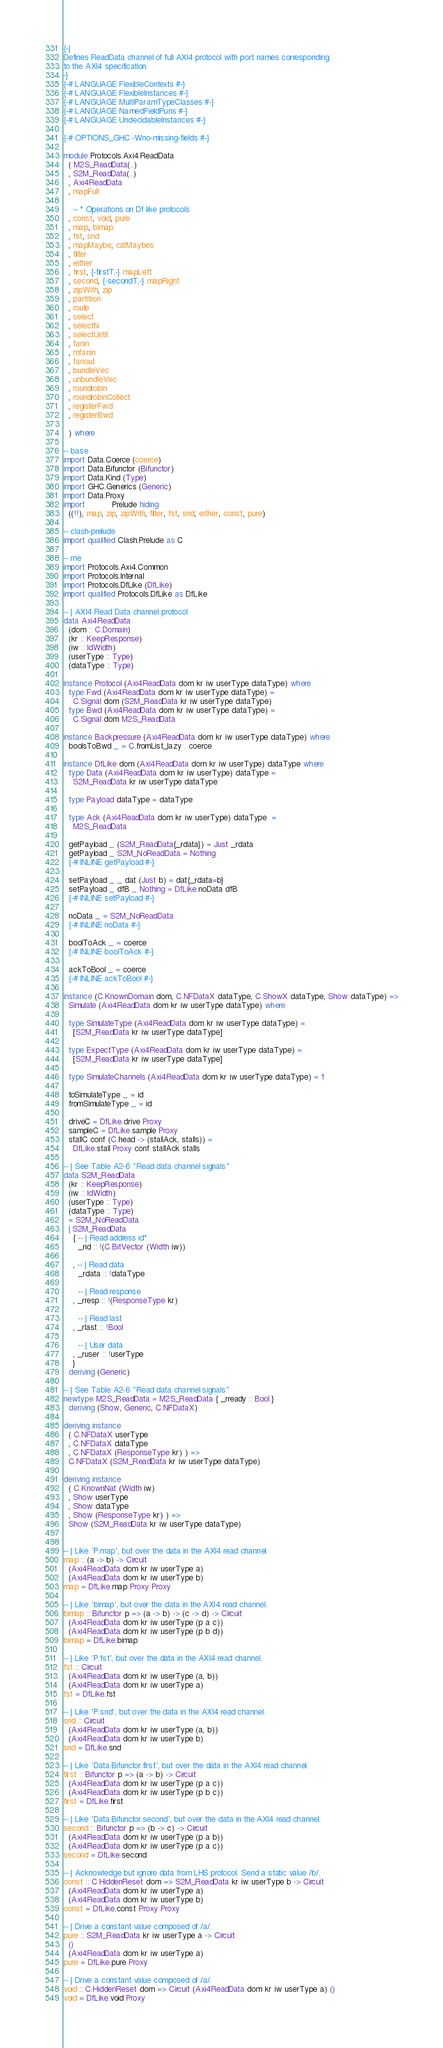<code> <loc_0><loc_0><loc_500><loc_500><_Haskell_>{-|
Defines ReadData channel of full AXI4 protocol with port names corresponding
to the AXI4 specification.
-}
{-# LANGUAGE FlexibleContexts #-}
{-# LANGUAGE FlexibleInstances #-}
{-# LANGUAGE MultiParamTypeClasses #-}
{-# LANGUAGE NamedFieldPuns #-}
{-# LANGUAGE UndecidableInstances #-}

{-# OPTIONS_GHC -Wno-missing-fields #-}

module Protocols.Axi4.ReadData
  ( M2S_ReadData(..)
  , S2M_ReadData(..)
  , Axi4ReadData
  , mapFull

    -- * Operations on Df like protocols
  , const, void, pure
  , map, bimap
  , fst, snd
  , mapMaybe, catMaybes
  , filter
  , either
  , first, {-firstT,-} mapLeft
  , second, {-secondT,-} mapRight
  , zipWith, zip
  , partition
  , route
  , select
  , selectN
  , selectUntil
  , fanin
  , mfanin
  , fanout
  , bundleVec
  , unbundleVec
  , roundrobin
  , roundrobinCollect
  , registerFwd
  , registerBwd

  ) where

-- base
import Data.Coerce (coerce)
import Data.Bifunctor (Bifunctor)
import Data.Kind (Type)
import GHC.Generics (Generic)
import Data.Proxy
import           Prelude hiding
  ((!!), map, zip, zipWith, filter, fst, snd, either, const, pure)

-- clash-prelude
import qualified Clash.Prelude as C

-- me
import Protocols.Axi4.Common
import Protocols.Internal
import Protocols.DfLike (DfLike)
import qualified Protocols.DfLike as DfLike

-- | AXI4 Read Data channel protocol
data Axi4ReadData
  (dom :: C.Domain)
  (kr :: KeepResponse)
  (iw :: IdWidth)
  (userType :: Type)
  (dataType :: Type)

instance Protocol (Axi4ReadData dom kr iw userType dataType) where
  type Fwd (Axi4ReadData dom kr iw userType dataType) =
    C.Signal dom (S2M_ReadData kr iw userType dataType)
  type Bwd (Axi4ReadData dom kr iw userType dataType) =
    C.Signal dom M2S_ReadData

instance Backpressure (Axi4ReadData dom kr iw userType dataType) where
  boolsToBwd _ = C.fromList_lazy . coerce

instance DfLike dom (Axi4ReadData dom kr iw userType) dataType where
  type Data (Axi4ReadData dom kr iw userType) dataType =
    S2M_ReadData kr iw userType dataType

  type Payload dataType = dataType

  type Ack (Axi4ReadData dom kr iw userType) dataType  =
    M2S_ReadData

  getPayload _ (S2M_ReadData{_rdata}) = Just _rdata
  getPayload _ S2M_NoReadData = Nothing
  {-# INLINE getPayload #-}

  setPayload _ _ dat (Just b) = dat{_rdata=b}
  setPayload _ dfB _ Nothing = DfLike.noData dfB
  {-# INLINE setPayload #-}

  noData _ = S2M_NoReadData
  {-# INLINE noData #-}

  boolToAck _ = coerce
  {-# INLINE boolToAck #-}

  ackToBool _ = coerce
  {-# INLINE ackToBool #-}

instance (C.KnownDomain dom, C.NFDataX dataType, C.ShowX dataType, Show dataType) =>
  Simulate (Axi4ReadData dom kr iw userType dataType) where

  type SimulateType (Axi4ReadData dom kr iw userType dataType) =
    [S2M_ReadData kr iw userType dataType]

  type ExpectType (Axi4ReadData dom kr iw userType dataType) =
    [S2M_ReadData kr iw userType dataType]

  type SimulateChannels (Axi4ReadData dom kr iw userType dataType) = 1

  toSimulateType _ = id
  fromSimulateType _ = id

  driveC = DfLike.drive Proxy
  sampleC = DfLike.sample Proxy
  stallC conf (C.head -> (stallAck, stalls)) =
    DfLike.stall Proxy conf stallAck stalls

-- | See Table A2-6 "Read data channel signals"
data S2M_ReadData
  (kr :: KeepResponse)
  (iw :: IdWidth)
  (userType :: Type)
  (dataType :: Type)
  = S2M_NoReadData
  | S2M_ReadData
    { -- | Read address id*
      _rid :: !(C.BitVector (Width iw))

    , -- | Read data
      _rdata :: !dataType

      -- | Read response
    , _rresp :: !(ResponseType kr)

      -- | Read last
    , _rlast :: !Bool

      -- | User data
    , _ruser :: !userType
    }
  deriving (Generic)

-- | See Table A2-6 "Read data channel signals"
newtype M2S_ReadData = M2S_ReadData { _rready :: Bool }
  deriving (Show, Generic, C.NFDataX)

deriving instance
  ( C.NFDataX userType
  , C.NFDataX dataType
  , C.NFDataX (ResponseType kr) ) =>
  C.NFDataX (S2M_ReadData kr iw userType dataType)

deriving instance
  ( C.KnownNat (Width iw)
  , Show userType
  , Show dataType
  , Show (ResponseType kr) ) =>
  Show (S2M_ReadData kr iw userType dataType)


-- | Like 'P.map', but over the data in the AXI4 read channel.
map :: (a -> b) -> Circuit
  (Axi4ReadData dom kr iw userType a)
  (Axi4ReadData dom kr iw userType b)
map = DfLike.map Proxy Proxy

-- | Like 'bimap', but over the data in the AXI4 read channel.
bimap :: Bifunctor p => (a -> b) -> (c -> d) -> Circuit
  (Axi4ReadData dom kr iw userType (p a c))
  (Axi4ReadData dom kr iw userType (p b d))
bimap = DfLike.bimap

-- | Like 'P.fst', but over the data in the AXI4 read channel.
fst :: Circuit
  (Axi4ReadData dom kr iw userType (a, b))
  (Axi4ReadData dom kr iw userType a)
fst = DfLike.fst

-- | Like 'P.snd', but over the data in the AXI4 read channel.
snd :: Circuit
  (Axi4ReadData dom kr iw userType (a, b))
  (Axi4ReadData dom kr iw userType b)
snd = DfLike.snd

-- | Like 'Data.Bifunctor.first', but over the data in the AXI4 read channel.
first :: Bifunctor p => (a -> b) -> Circuit
  (Axi4ReadData dom kr iw userType (p a c))
  (Axi4ReadData dom kr iw userType (p b c))
first = DfLike.first

-- | Like 'Data.Bifunctor.second', but over the data in the AXI4 read channel.
second :: Bifunctor p => (b -> c) -> Circuit
  (Axi4ReadData dom kr iw userType (p a b))
  (Axi4ReadData dom kr iw userType (p a c))
second = DfLike.second

-- | Acknowledge but ignore data from LHS protocol. Send a static value /b/.
const :: C.HiddenReset dom => S2M_ReadData kr iw userType b -> Circuit
  (Axi4ReadData dom kr iw userType a)
  (Axi4ReadData dom kr iw userType b)
const = DfLike.const Proxy Proxy

-- | Drive a constant value composed of /a/.
pure :: S2M_ReadData kr iw userType a -> Circuit
  ()
  (Axi4ReadData dom kr iw userType a)
pure = DfLike.pure Proxy

-- | Drive a constant value composed of /a/.
void :: C.HiddenReset dom => Circuit (Axi4ReadData dom kr iw userType a) ()
void = DfLike.void Proxy
</code> 